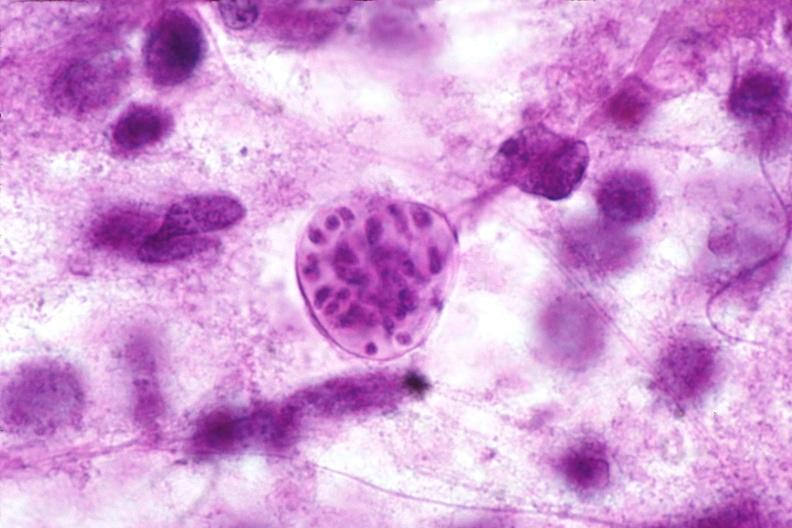s nervous present?
Answer the question using a single word or phrase. Yes 